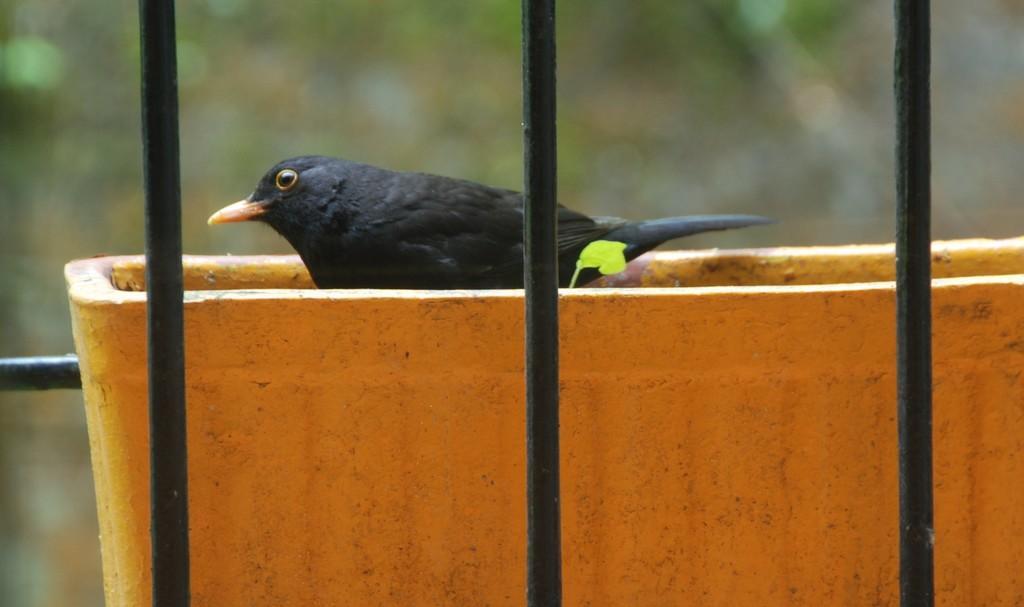Please provide a concise description of this image. In this picture we can see one black bird is standing in the tub. 